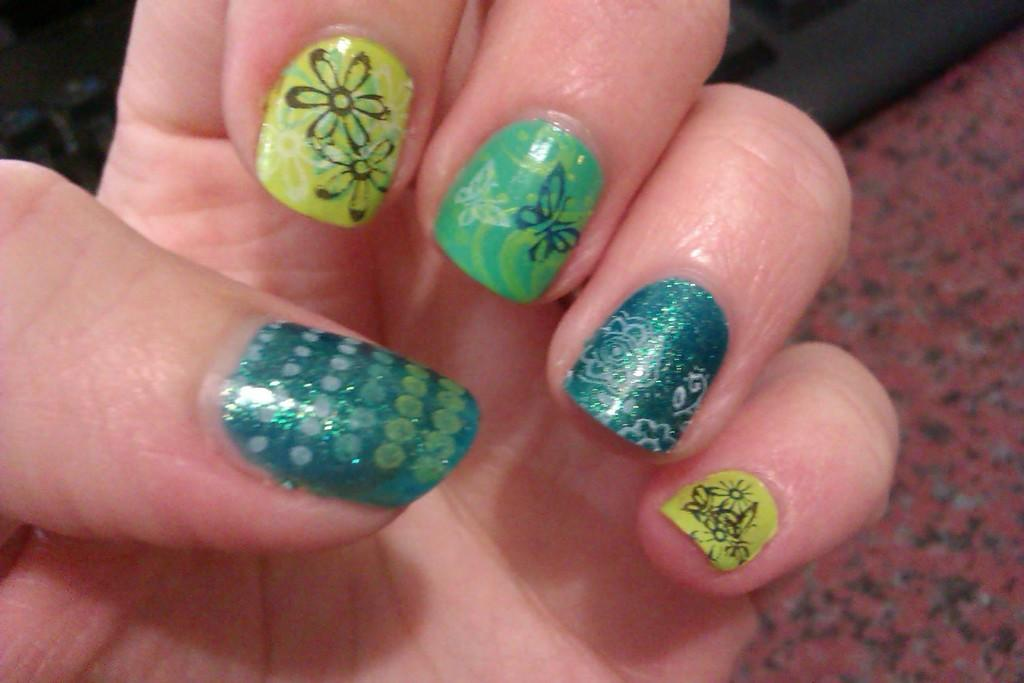What is on the person's fingers in the image? There is nail polish on the person's fingers. What can be seen on the ground in the image? There is a black color object on the ground. What type of poison is being used in the image? There is no poison present in the image. What class is the person attending in the image? There is no indication of a class or any educational setting in the image. 